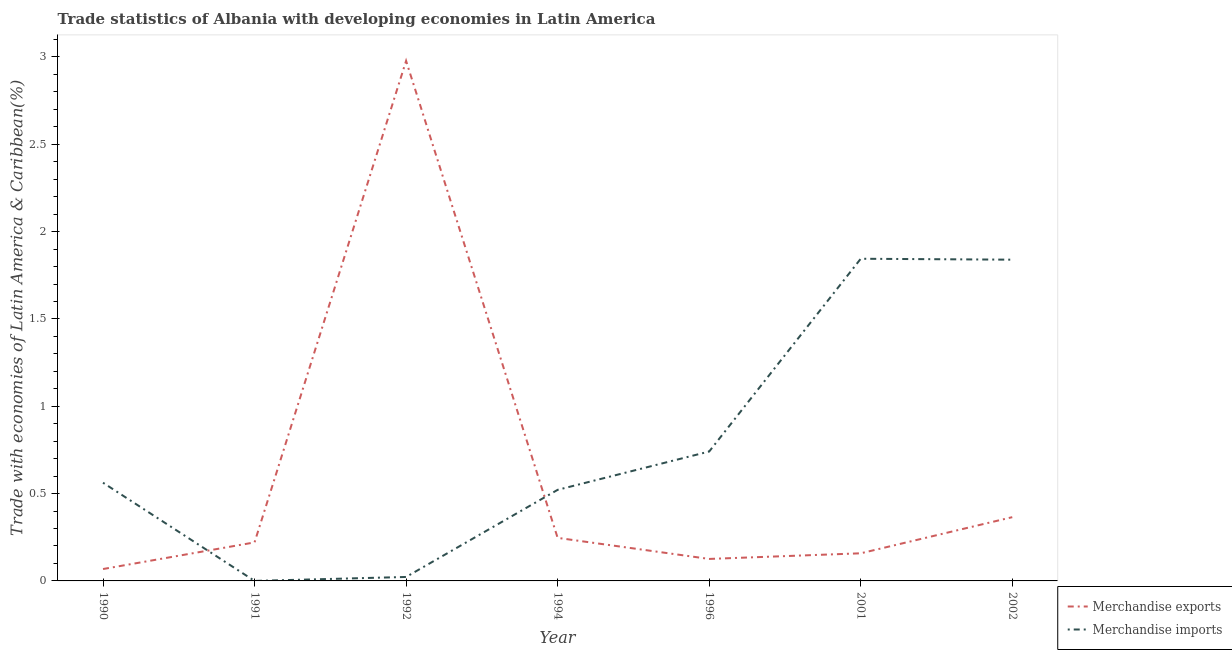Does the line corresponding to merchandise exports intersect with the line corresponding to merchandise imports?
Make the answer very short. Yes. Is the number of lines equal to the number of legend labels?
Offer a very short reply. Yes. What is the merchandise exports in 1996?
Keep it short and to the point. 0.13. Across all years, what is the maximum merchandise exports?
Your answer should be compact. 2.98. Across all years, what is the minimum merchandise imports?
Your answer should be very brief. 6.82564304270047e-5. What is the total merchandise exports in the graph?
Make the answer very short. 4.16. What is the difference between the merchandise exports in 1990 and that in 1994?
Keep it short and to the point. -0.18. What is the difference between the merchandise imports in 1992 and the merchandise exports in 2001?
Make the answer very short. -0.14. What is the average merchandise imports per year?
Keep it short and to the point. 0.79. In the year 2002, what is the difference between the merchandise imports and merchandise exports?
Your answer should be compact. 1.47. In how many years, is the merchandise imports greater than 3 %?
Offer a terse response. 0. What is the ratio of the merchandise imports in 1992 to that in 1994?
Make the answer very short. 0.04. Is the merchandise exports in 1990 less than that in 1991?
Ensure brevity in your answer.  Yes. What is the difference between the highest and the second highest merchandise imports?
Your answer should be very brief. 0.01. What is the difference between the highest and the lowest merchandise imports?
Your answer should be very brief. 1.84. In how many years, is the merchandise exports greater than the average merchandise exports taken over all years?
Your answer should be very brief. 1. Is the sum of the merchandise imports in 1994 and 1996 greater than the maximum merchandise exports across all years?
Your answer should be very brief. No. Does the merchandise imports monotonically increase over the years?
Offer a terse response. No. Is the merchandise imports strictly greater than the merchandise exports over the years?
Keep it short and to the point. No. How many years are there in the graph?
Ensure brevity in your answer.  7. Are the values on the major ticks of Y-axis written in scientific E-notation?
Provide a short and direct response. No. Does the graph contain any zero values?
Your answer should be compact. No. Does the graph contain grids?
Make the answer very short. No. How many legend labels are there?
Offer a terse response. 2. What is the title of the graph?
Offer a terse response. Trade statistics of Albania with developing economies in Latin America. What is the label or title of the X-axis?
Provide a short and direct response. Year. What is the label or title of the Y-axis?
Offer a very short reply. Trade with economies of Latin America & Caribbean(%). What is the Trade with economies of Latin America & Caribbean(%) in Merchandise exports in 1990?
Provide a short and direct response. 0.07. What is the Trade with economies of Latin America & Caribbean(%) of Merchandise imports in 1990?
Your answer should be very brief. 0.56. What is the Trade with economies of Latin America & Caribbean(%) in Merchandise exports in 1991?
Offer a very short reply. 0.22. What is the Trade with economies of Latin America & Caribbean(%) of Merchandise imports in 1991?
Make the answer very short. 6.82564304270047e-5. What is the Trade with economies of Latin America & Caribbean(%) in Merchandise exports in 1992?
Give a very brief answer. 2.98. What is the Trade with economies of Latin America & Caribbean(%) of Merchandise imports in 1992?
Offer a terse response. 0.02. What is the Trade with economies of Latin America & Caribbean(%) in Merchandise exports in 1994?
Keep it short and to the point. 0.25. What is the Trade with economies of Latin America & Caribbean(%) in Merchandise imports in 1994?
Make the answer very short. 0.52. What is the Trade with economies of Latin America & Caribbean(%) of Merchandise exports in 1996?
Offer a very short reply. 0.13. What is the Trade with economies of Latin America & Caribbean(%) of Merchandise imports in 1996?
Offer a very short reply. 0.74. What is the Trade with economies of Latin America & Caribbean(%) of Merchandise exports in 2001?
Your answer should be compact. 0.16. What is the Trade with economies of Latin America & Caribbean(%) in Merchandise imports in 2001?
Ensure brevity in your answer.  1.84. What is the Trade with economies of Latin America & Caribbean(%) in Merchandise exports in 2002?
Provide a succinct answer. 0.37. What is the Trade with economies of Latin America & Caribbean(%) in Merchandise imports in 2002?
Your answer should be very brief. 1.84. Across all years, what is the maximum Trade with economies of Latin America & Caribbean(%) in Merchandise exports?
Your answer should be compact. 2.98. Across all years, what is the maximum Trade with economies of Latin America & Caribbean(%) in Merchandise imports?
Give a very brief answer. 1.84. Across all years, what is the minimum Trade with economies of Latin America & Caribbean(%) in Merchandise exports?
Offer a very short reply. 0.07. Across all years, what is the minimum Trade with economies of Latin America & Caribbean(%) of Merchandise imports?
Your response must be concise. 6.82564304270047e-5. What is the total Trade with economies of Latin America & Caribbean(%) in Merchandise exports in the graph?
Your response must be concise. 4.16. What is the total Trade with economies of Latin America & Caribbean(%) of Merchandise imports in the graph?
Offer a very short reply. 5.53. What is the difference between the Trade with economies of Latin America & Caribbean(%) of Merchandise exports in 1990 and that in 1991?
Give a very brief answer. -0.15. What is the difference between the Trade with economies of Latin America & Caribbean(%) in Merchandise imports in 1990 and that in 1991?
Offer a very short reply. 0.56. What is the difference between the Trade with economies of Latin America & Caribbean(%) in Merchandise exports in 1990 and that in 1992?
Your response must be concise. -2.91. What is the difference between the Trade with economies of Latin America & Caribbean(%) of Merchandise imports in 1990 and that in 1992?
Give a very brief answer. 0.54. What is the difference between the Trade with economies of Latin America & Caribbean(%) of Merchandise exports in 1990 and that in 1994?
Provide a succinct answer. -0.18. What is the difference between the Trade with economies of Latin America & Caribbean(%) of Merchandise imports in 1990 and that in 1994?
Your response must be concise. 0.04. What is the difference between the Trade with economies of Latin America & Caribbean(%) of Merchandise exports in 1990 and that in 1996?
Offer a very short reply. -0.06. What is the difference between the Trade with economies of Latin America & Caribbean(%) in Merchandise imports in 1990 and that in 1996?
Provide a succinct answer. -0.18. What is the difference between the Trade with economies of Latin America & Caribbean(%) in Merchandise exports in 1990 and that in 2001?
Give a very brief answer. -0.09. What is the difference between the Trade with economies of Latin America & Caribbean(%) of Merchandise imports in 1990 and that in 2001?
Offer a terse response. -1.28. What is the difference between the Trade with economies of Latin America & Caribbean(%) in Merchandise exports in 1990 and that in 2002?
Your answer should be compact. -0.3. What is the difference between the Trade with economies of Latin America & Caribbean(%) in Merchandise imports in 1990 and that in 2002?
Provide a succinct answer. -1.28. What is the difference between the Trade with economies of Latin America & Caribbean(%) in Merchandise exports in 1991 and that in 1992?
Ensure brevity in your answer.  -2.76. What is the difference between the Trade with economies of Latin America & Caribbean(%) of Merchandise imports in 1991 and that in 1992?
Make the answer very short. -0.02. What is the difference between the Trade with economies of Latin America & Caribbean(%) of Merchandise exports in 1991 and that in 1994?
Your response must be concise. -0.03. What is the difference between the Trade with economies of Latin America & Caribbean(%) of Merchandise imports in 1991 and that in 1994?
Make the answer very short. -0.52. What is the difference between the Trade with economies of Latin America & Caribbean(%) in Merchandise exports in 1991 and that in 1996?
Your answer should be compact. 0.09. What is the difference between the Trade with economies of Latin America & Caribbean(%) in Merchandise imports in 1991 and that in 1996?
Provide a succinct answer. -0.74. What is the difference between the Trade with economies of Latin America & Caribbean(%) in Merchandise exports in 1991 and that in 2001?
Provide a succinct answer. 0.06. What is the difference between the Trade with economies of Latin America & Caribbean(%) of Merchandise imports in 1991 and that in 2001?
Provide a short and direct response. -1.84. What is the difference between the Trade with economies of Latin America & Caribbean(%) of Merchandise exports in 1991 and that in 2002?
Provide a short and direct response. -0.14. What is the difference between the Trade with economies of Latin America & Caribbean(%) of Merchandise imports in 1991 and that in 2002?
Provide a short and direct response. -1.84. What is the difference between the Trade with economies of Latin America & Caribbean(%) in Merchandise exports in 1992 and that in 1994?
Make the answer very short. 2.73. What is the difference between the Trade with economies of Latin America & Caribbean(%) in Merchandise imports in 1992 and that in 1994?
Provide a succinct answer. -0.5. What is the difference between the Trade with economies of Latin America & Caribbean(%) of Merchandise exports in 1992 and that in 1996?
Give a very brief answer. 2.85. What is the difference between the Trade with economies of Latin America & Caribbean(%) in Merchandise imports in 1992 and that in 1996?
Ensure brevity in your answer.  -0.72. What is the difference between the Trade with economies of Latin America & Caribbean(%) of Merchandise exports in 1992 and that in 2001?
Your answer should be compact. 2.82. What is the difference between the Trade with economies of Latin America & Caribbean(%) in Merchandise imports in 1992 and that in 2001?
Offer a terse response. -1.82. What is the difference between the Trade with economies of Latin America & Caribbean(%) in Merchandise exports in 1992 and that in 2002?
Provide a succinct answer. 2.61. What is the difference between the Trade with economies of Latin America & Caribbean(%) in Merchandise imports in 1992 and that in 2002?
Give a very brief answer. -1.82. What is the difference between the Trade with economies of Latin America & Caribbean(%) of Merchandise exports in 1994 and that in 1996?
Ensure brevity in your answer.  0.12. What is the difference between the Trade with economies of Latin America & Caribbean(%) in Merchandise imports in 1994 and that in 1996?
Ensure brevity in your answer.  -0.22. What is the difference between the Trade with economies of Latin America & Caribbean(%) of Merchandise exports in 1994 and that in 2001?
Offer a very short reply. 0.09. What is the difference between the Trade with economies of Latin America & Caribbean(%) of Merchandise imports in 1994 and that in 2001?
Provide a short and direct response. -1.32. What is the difference between the Trade with economies of Latin America & Caribbean(%) of Merchandise exports in 1994 and that in 2002?
Provide a short and direct response. -0.12. What is the difference between the Trade with economies of Latin America & Caribbean(%) of Merchandise imports in 1994 and that in 2002?
Ensure brevity in your answer.  -1.32. What is the difference between the Trade with economies of Latin America & Caribbean(%) of Merchandise exports in 1996 and that in 2001?
Provide a succinct answer. -0.03. What is the difference between the Trade with economies of Latin America & Caribbean(%) of Merchandise imports in 1996 and that in 2001?
Keep it short and to the point. -1.1. What is the difference between the Trade with economies of Latin America & Caribbean(%) in Merchandise exports in 1996 and that in 2002?
Ensure brevity in your answer.  -0.24. What is the difference between the Trade with economies of Latin America & Caribbean(%) in Merchandise imports in 1996 and that in 2002?
Give a very brief answer. -1.1. What is the difference between the Trade with economies of Latin America & Caribbean(%) in Merchandise exports in 2001 and that in 2002?
Ensure brevity in your answer.  -0.21. What is the difference between the Trade with economies of Latin America & Caribbean(%) of Merchandise imports in 2001 and that in 2002?
Your response must be concise. 0.01. What is the difference between the Trade with economies of Latin America & Caribbean(%) in Merchandise exports in 1990 and the Trade with economies of Latin America & Caribbean(%) in Merchandise imports in 1991?
Give a very brief answer. 0.07. What is the difference between the Trade with economies of Latin America & Caribbean(%) in Merchandise exports in 1990 and the Trade with economies of Latin America & Caribbean(%) in Merchandise imports in 1992?
Provide a short and direct response. 0.05. What is the difference between the Trade with economies of Latin America & Caribbean(%) in Merchandise exports in 1990 and the Trade with economies of Latin America & Caribbean(%) in Merchandise imports in 1994?
Offer a terse response. -0.45. What is the difference between the Trade with economies of Latin America & Caribbean(%) in Merchandise exports in 1990 and the Trade with economies of Latin America & Caribbean(%) in Merchandise imports in 1996?
Your answer should be compact. -0.67. What is the difference between the Trade with economies of Latin America & Caribbean(%) in Merchandise exports in 1990 and the Trade with economies of Latin America & Caribbean(%) in Merchandise imports in 2001?
Keep it short and to the point. -1.78. What is the difference between the Trade with economies of Latin America & Caribbean(%) in Merchandise exports in 1990 and the Trade with economies of Latin America & Caribbean(%) in Merchandise imports in 2002?
Offer a very short reply. -1.77. What is the difference between the Trade with economies of Latin America & Caribbean(%) in Merchandise exports in 1991 and the Trade with economies of Latin America & Caribbean(%) in Merchandise imports in 1992?
Ensure brevity in your answer.  0.2. What is the difference between the Trade with economies of Latin America & Caribbean(%) of Merchandise exports in 1991 and the Trade with economies of Latin America & Caribbean(%) of Merchandise imports in 1994?
Your answer should be very brief. -0.3. What is the difference between the Trade with economies of Latin America & Caribbean(%) of Merchandise exports in 1991 and the Trade with economies of Latin America & Caribbean(%) of Merchandise imports in 1996?
Provide a succinct answer. -0.52. What is the difference between the Trade with economies of Latin America & Caribbean(%) of Merchandise exports in 1991 and the Trade with economies of Latin America & Caribbean(%) of Merchandise imports in 2001?
Give a very brief answer. -1.62. What is the difference between the Trade with economies of Latin America & Caribbean(%) of Merchandise exports in 1991 and the Trade with economies of Latin America & Caribbean(%) of Merchandise imports in 2002?
Your response must be concise. -1.62. What is the difference between the Trade with economies of Latin America & Caribbean(%) of Merchandise exports in 1992 and the Trade with economies of Latin America & Caribbean(%) of Merchandise imports in 1994?
Make the answer very short. 2.46. What is the difference between the Trade with economies of Latin America & Caribbean(%) in Merchandise exports in 1992 and the Trade with economies of Latin America & Caribbean(%) in Merchandise imports in 1996?
Keep it short and to the point. 2.24. What is the difference between the Trade with economies of Latin America & Caribbean(%) in Merchandise exports in 1992 and the Trade with economies of Latin America & Caribbean(%) in Merchandise imports in 2001?
Your answer should be compact. 1.13. What is the difference between the Trade with economies of Latin America & Caribbean(%) of Merchandise exports in 1992 and the Trade with economies of Latin America & Caribbean(%) of Merchandise imports in 2002?
Your response must be concise. 1.14. What is the difference between the Trade with economies of Latin America & Caribbean(%) in Merchandise exports in 1994 and the Trade with economies of Latin America & Caribbean(%) in Merchandise imports in 1996?
Give a very brief answer. -0.49. What is the difference between the Trade with economies of Latin America & Caribbean(%) of Merchandise exports in 1994 and the Trade with economies of Latin America & Caribbean(%) of Merchandise imports in 2001?
Offer a terse response. -1.6. What is the difference between the Trade with economies of Latin America & Caribbean(%) in Merchandise exports in 1994 and the Trade with economies of Latin America & Caribbean(%) in Merchandise imports in 2002?
Your answer should be compact. -1.59. What is the difference between the Trade with economies of Latin America & Caribbean(%) in Merchandise exports in 1996 and the Trade with economies of Latin America & Caribbean(%) in Merchandise imports in 2001?
Provide a succinct answer. -1.72. What is the difference between the Trade with economies of Latin America & Caribbean(%) of Merchandise exports in 1996 and the Trade with economies of Latin America & Caribbean(%) of Merchandise imports in 2002?
Keep it short and to the point. -1.71. What is the difference between the Trade with economies of Latin America & Caribbean(%) of Merchandise exports in 2001 and the Trade with economies of Latin America & Caribbean(%) of Merchandise imports in 2002?
Your response must be concise. -1.68. What is the average Trade with economies of Latin America & Caribbean(%) in Merchandise exports per year?
Ensure brevity in your answer.  0.59. What is the average Trade with economies of Latin America & Caribbean(%) in Merchandise imports per year?
Your answer should be compact. 0.79. In the year 1990, what is the difference between the Trade with economies of Latin America & Caribbean(%) of Merchandise exports and Trade with economies of Latin America & Caribbean(%) of Merchandise imports?
Your response must be concise. -0.49. In the year 1991, what is the difference between the Trade with economies of Latin America & Caribbean(%) in Merchandise exports and Trade with economies of Latin America & Caribbean(%) in Merchandise imports?
Your answer should be very brief. 0.22. In the year 1992, what is the difference between the Trade with economies of Latin America & Caribbean(%) in Merchandise exports and Trade with economies of Latin America & Caribbean(%) in Merchandise imports?
Offer a terse response. 2.96. In the year 1994, what is the difference between the Trade with economies of Latin America & Caribbean(%) of Merchandise exports and Trade with economies of Latin America & Caribbean(%) of Merchandise imports?
Your answer should be very brief. -0.28. In the year 1996, what is the difference between the Trade with economies of Latin America & Caribbean(%) in Merchandise exports and Trade with economies of Latin America & Caribbean(%) in Merchandise imports?
Keep it short and to the point. -0.62. In the year 2001, what is the difference between the Trade with economies of Latin America & Caribbean(%) of Merchandise exports and Trade with economies of Latin America & Caribbean(%) of Merchandise imports?
Your response must be concise. -1.69. In the year 2002, what is the difference between the Trade with economies of Latin America & Caribbean(%) of Merchandise exports and Trade with economies of Latin America & Caribbean(%) of Merchandise imports?
Your answer should be very brief. -1.47. What is the ratio of the Trade with economies of Latin America & Caribbean(%) of Merchandise exports in 1990 to that in 1991?
Your answer should be compact. 0.31. What is the ratio of the Trade with economies of Latin America & Caribbean(%) in Merchandise imports in 1990 to that in 1991?
Give a very brief answer. 8238.29. What is the ratio of the Trade with economies of Latin America & Caribbean(%) in Merchandise exports in 1990 to that in 1992?
Make the answer very short. 0.02. What is the ratio of the Trade with economies of Latin America & Caribbean(%) of Merchandise imports in 1990 to that in 1992?
Your answer should be compact. 24.84. What is the ratio of the Trade with economies of Latin America & Caribbean(%) in Merchandise exports in 1990 to that in 1994?
Make the answer very short. 0.28. What is the ratio of the Trade with economies of Latin America & Caribbean(%) in Merchandise imports in 1990 to that in 1994?
Your response must be concise. 1.08. What is the ratio of the Trade with economies of Latin America & Caribbean(%) of Merchandise exports in 1990 to that in 1996?
Provide a short and direct response. 0.54. What is the ratio of the Trade with economies of Latin America & Caribbean(%) in Merchandise imports in 1990 to that in 1996?
Your response must be concise. 0.76. What is the ratio of the Trade with economies of Latin America & Caribbean(%) of Merchandise exports in 1990 to that in 2001?
Your response must be concise. 0.43. What is the ratio of the Trade with economies of Latin America & Caribbean(%) in Merchandise imports in 1990 to that in 2001?
Your response must be concise. 0.3. What is the ratio of the Trade with economies of Latin America & Caribbean(%) in Merchandise exports in 1990 to that in 2002?
Offer a terse response. 0.19. What is the ratio of the Trade with economies of Latin America & Caribbean(%) of Merchandise imports in 1990 to that in 2002?
Your answer should be very brief. 0.31. What is the ratio of the Trade with economies of Latin America & Caribbean(%) in Merchandise exports in 1991 to that in 1992?
Provide a succinct answer. 0.07. What is the ratio of the Trade with economies of Latin America & Caribbean(%) of Merchandise imports in 1991 to that in 1992?
Offer a terse response. 0. What is the ratio of the Trade with economies of Latin America & Caribbean(%) of Merchandise exports in 1991 to that in 1994?
Provide a short and direct response. 0.89. What is the ratio of the Trade with economies of Latin America & Caribbean(%) in Merchandise exports in 1991 to that in 1996?
Give a very brief answer. 1.75. What is the ratio of the Trade with economies of Latin America & Caribbean(%) of Merchandise exports in 1991 to that in 2001?
Provide a succinct answer. 1.39. What is the ratio of the Trade with economies of Latin America & Caribbean(%) of Merchandise exports in 1991 to that in 2002?
Provide a short and direct response. 0.6. What is the ratio of the Trade with economies of Latin America & Caribbean(%) of Merchandise imports in 1991 to that in 2002?
Keep it short and to the point. 0. What is the ratio of the Trade with economies of Latin America & Caribbean(%) of Merchandise exports in 1992 to that in 1994?
Make the answer very short. 12.08. What is the ratio of the Trade with economies of Latin America & Caribbean(%) in Merchandise imports in 1992 to that in 1994?
Offer a terse response. 0.04. What is the ratio of the Trade with economies of Latin America & Caribbean(%) of Merchandise exports in 1992 to that in 1996?
Keep it short and to the point. 23.65. What is the ratio of the Trade with economies of Latin America & Caribbean(%) of Merchandise imports in 1992 to that in 1996?
Your answer should be very brief. 0.03. What is the ratio of the Trade with economies of Latin America & Caribbean(%) in Merchandise exports in 1992 to that in 2001?
Your answer should be compact. 18.83. What is the ratio of the Trade with economies of Latin America & Caribbean(%) in Merchandise imports in 1992 to that in 2001?
Your answer should be very brief. 0.01. What is the ratio of the Trade with economies of Latin America & Caribbean(%) of Merchandise exports in 1992 to that in 2002?
Make the answer very short. 8.16. What is the ratio of the Trade with economies of Latin America & Caribbean(%) of Merchandise imports in 1992 to that in 2002?
Make the answer very short. 0.01. What is the ratio of the Trade with economies of Latin America & Caribbean(%) in Merchandise exports in 1994 to that in 1996?
Keep it short and to the point. 1.96. What is the ratio of the Trade with economies of Latin America & Caribbean(%) in Merchandise imports in 1994 to that in 1996?
Your answer should be compact. 0.7. What is the ratio of the Trade with economies of Latin America & Caribbean(%) of Merchandise exports in 1994 to that in 2001?
Your answer should be compact. 1.56. What is the ratio of the Trade with economies of Latin America & Caribbean(%) in Merchandise imports in 1994 to that in 2001?
Provide a succinct answer. 0.28. What is the ratio of the Trade with economies of Latin America & Caribbean(%) of Merchandise exports in 1994 to that in 2002?
Your answer should be compact. 0.68. What is the ratio of the Trade with economies of Latin America & Caribbean(%) in Merchandise imports in 1994 to that in 2002?
Your answer should be very brief. 0.28. What is the ratio of the Trade with economies of Latin America & Caribbean(%) in Merchandise exports in 1996 to that in 2001?
Your answer should be very brief. 0.8. What is the ratio of the Trade with economies of Latin America & Caribbean(%) of Merchandise imports in 1996 to that in 2001?
Give a very brief answer. 0.4. What is the ratio of the Trade with economies of Latin America & Caribbean(%) of Merchandise exports in 1996 to that in 2002?
Give a very brief answer. 0.34. What is the ratio of the Trade with economies of Latin America & Caribbean(%) in Merchandise imports in 1996 to that in 2002?
Make the answer very short. 0.4. What is the ratio of the Trade with economies of Latin America & Caribbean(%) of Merchandise exports in 2001 to that in 2002?
Offer a very short reply. 0.43. What is the difference between the highest and the second highest Trade with economies of Latin America & Caribbean(%) of Merchandise exports?
Offer a terse response. 2.61. What is the difference between the highest and the second highest Trade with economies of Latin America & Caribbean(%) of Merchandise imports?
Offer a terse response. 0.01. What is the difference between the highest and the lowest Trade with economies of Latin America & Caribbean(%) in Merchandise exports?
Give a very brief answer. 2.91. What is the difference between the highest and the lowest Trade with economies of Latin America & Caribbean(%) in Merchandise imports?
Your answer should be very brief. 1.84. 